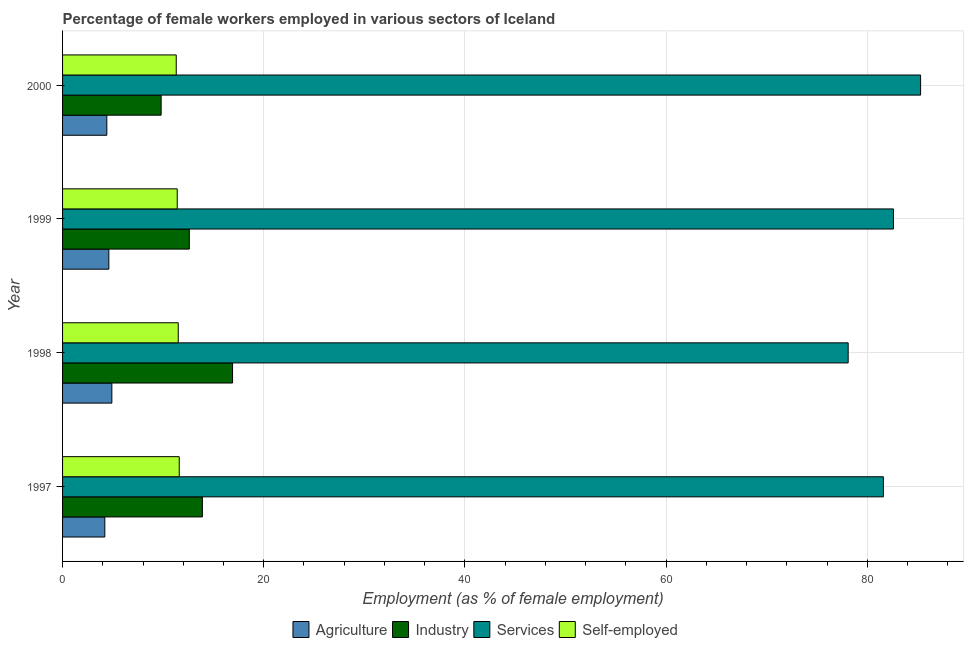How many groups of bars are there?
Provide a short and direct response. 4. Are the number of bars per tick equal to the number of legend labels?
Ensure brevity in your answer.  Yes. Are the number of bars on each tick of the Y-axis equal?
Ensure brevity in your answer.  Yes. How many bars are there on the 1st tick from the top?
Ensure brevity in your answer.  4. What is the percentage of self employed female workers in 1997?
Offer a very short reply. 11.6. Across all years, what is the maximum percentage of self employed female workers?
Your response must be concise. 11.6. Across all years, what is the minimum percentage of female workers in industry?
Provide a succinct answer. 9.8. In which year was the percentage of female workers in services minimum?
Provide a short and direct response. 1998. What is the total percentage of female workers in agriculture in the graph?
Make the answer very short. 18.1. What is the difference between the percentage of female workers in industry in 2000 and the percentage of female workers in services in 1999?
Provide a short and direct response. -72.8. What is the average percentage of self employed female workers per year?
Offer a terse response. 11.45. In the year 2000, what is the difference between the percentage of female workers in services and percentage of female workers in agriculture?
Give a very brief answer. 80.9. In how many years, is the percentage of female workers in agriculture greater than 64 %?
Offer a very short reply. 0. What is the ratio of the percentage of female workers in agriculture in 1998 to that in 2000?
Your response must be concise. 1.11. Is the percentage of female workers in agriculture in 1999 less than that in 2000?
Your answer should be very brief. No. Is the difference between the percentage of female workers in agriculture in 1997 and 1999 greater than the difference between the percentage of self employed female workers in 1997 and 1999?
Provide a short and direct response. No. What is the difference between the highest and the second highest percentage of female workers in services?
Ensure brevity in your answer.  2.7. What is the difference between the highest and the lowest percentage of female workers in industry?
Your response must be concise. 7.1. In how many years, is the percentage of female workers in industry greater than the average percentage of female workers in industry taken over all years?
Ensure brevity in your answer.  2. Is the sum of the percentage of female workers in industry in 1997 and 1999 greater than the maximum percentage of self employed female workers across all years?
Make the answer very short. Yes. What does the 2nd bar from the top in 1999 represents?
Keep it short and to the point. Services. What does the 1st bar from the bottom in 1998 represents?
Your answer should be very brief. Agriculture. How many bars are there?
Offer a terse response. 16. Are the values on the major ticks of X-axis written in scientific E-notation?
Make the answer very short. No. Does the graph contain any zero values?
Provide a succinct answer. No. Where does the legend appear in the graph?
Provide a succinct answer. Bottom center. How are the legend labels stacked?
Keep it short and to the point. Horizontal. What is the title of the graph?
Ensure brevity in your answer.  Percentage of female workers employed in various sectors of Iceland. What is the label or title of the X-axis?
Ensure brevity in your answer.  Employment (as % of female employment). What is the Employment (as % of female employment) of Agriculture in 1997?
Offer a very short reply. 4.2. What is the Employment (as % of female employment) in Industry in 1997?
Give a very brief answer. 13.9. What is the Employment (as % of female employment) in Services in 1997?
Make the answer very short. 81.6. What is the Employment (as % of female employment) in Self-employed in 1997?
Your response must be concise. 11.6. What is the Employment (as % of female employment) in Agriculture in 1998?
Give a very brief answer. 4.9. What is the Employment (as % of female employment) in Industry in 1998?
Ensure brevity in your answer.  16.9. What is the Employment (as % of female employment) of Services in 1998?
Offer a terse response. 78.1. What is the Employment (as % of female employment) of Self-employed in 1998?
Offer a terse response. 11.5. What is the Employment (as % of female employment) of Agriculture in 1999?
Offer a terse response. 4.6. What is the Employment (as % of female employment) of Industry in 1999?
Give a very brief answer. 12.6. What is the Employment (as % of female employment) of Services in 1999?
Give a very brief answer. 82.6. What is the Employment (as % of female employment) of Self-employed in 1999?
Ensure brevity in your answer.  11.4. What is the Employment (as % of female employment) in Agriculture in 2000?
Give a very brief answer. 4.4. What is the Employment (as % of female employment) in Industry in 2000?
Offer a terse response. 9.8. What is the Employment (as % of female employment) in Services in 2000?
Your answer should be compact. 85.3. What is the Employment (as % of female employment) of Self-employed in 2000?
Keep it short and to the point. 11.3. Across all years, what is the maximum Employment (as % of female employment) of Agriculture?
Provide a short and direct response. 4.9. Across all years, what is the maximum Employment (as % of female employment) in Industry?
Provide a succinct answer. 16.9. Across all years, what is the maximum Employment (as % of female employment) of Services?
Provide a short and direct response. 85.3. Across all years, what is the maximum Employment (as % of female employment) of Self-employed?
Provide a short and direct response. 11.6. Across all years, what is the minimum Employment (as % of female employment) of Agriculture?
Offer a terse response. 4.2. Across all years, what is the minimum Employment (as % of female employment) in Industry?
Keep it short and to the point. 9.8. Across all years, what is the minimum Employment (as % of female employment) in Services?
Your answer should be very brief. 78.1. Across all years, what is the minimum Employment (as % of female employment) of Self-employed?
Give a very brief answer. 11.3. What is the total Employment (as % of female employment) in Agriculture in the graph?
Keep it short and to the point. 18.1. What is the total Employment (as % of female employment) of Industry in the graph?
Provide a short and direct response. 53.2. What is the total Employment (as % of female employment) of Services in the graph?
Offer a terse response. 327.6. What is the total Employment (as % of female employment) of Self-employed in the graph?
Keep it short and to the point. 45.8. What is the difference between the Employment (as % of female employment) of Agriculture in 1997 and that in 1998?
Provide a short and direct response. -0.7. What is the difference between the Employment (as % of female employment) in Industry in 1997 and that in 1998?
Provide a short and direct response. -3. What is the difference between the Employment (as % of female employment) in Agriculture in 1997 and that in 1999?
Offer a very short reply. -0.4. What is the difference between the Employment (as % of female employment) of Self-employed in 1997 and that in 1999?
Your answer should be very brief. 0.2. What is the difference between the Employment (as % of female employment) in Services in 1997 and that in 2000?
Offer a very short reply. -3.7. What is the difference between the Employment (as % of female employment) in Industry in 1998 and that in 1999?
Your answer should be very brief. 4.3. What is the difference between the Employment (as % of female employment) of Services in 1998 and that in 1999?
Make the answer very short. -4.5. What is the difference between the Employment (as % of female employment) of Self-employed in 1998 and that in 1999?
Provide a succinct answer. 0.1. What is the difference between the Employment (as % of female employment) in Agriculture in 1998 and that in 2000?
Your answer should be compact. 0.5. What is the difference between the Employment (as % of female employment) of Industry in 1998 and that in 2000?
Keep it short and to the point. 7.1. What is the difference between the Employment (as % of female employment) of Agriculture in 1997 and the Employment (as % of female employment) of Industry in 1998?
Make the answer very short. -12.7. What is the difference between the Employment (as % of female employment) of Agriculture in 1997 and the Employment (as % of female employment) of Services in 1998?
Give a very brief answer. -73.9. What is the difference between the Employment (as % of female employment) of Industry in 1997 and the Employment (as % of female employment) of Services in 1998?
Offer a terse response. -64.2. What is the difference between the Employment (as % of female employment) of Services in 1997 and the Employment (as % of female employment) of Self-employed in 1998?
Offer a terse response. 70.1. What is the difference between the Employment (as % of female employment) in Agriculture in 1997 and the Employment (as % of female employment) in Services in 1999?
Your answer should be compact. -78.4. What is the difference between the Employment (as % of female employment) in Industry in 1997 and the Employment (as % of female employment) in Services in 1999?
Your answer should be very brief. -68.7. What is the difference between the Employment (as % of female employment) of Services in 1997 and the Employment (as % of female employment) of Self-employed in 1999?
Ensure brevity in your answer.  70.2. What is the difference between the Employment (as % of female employment) of Agriculture in 1997 and the Employment (as % of female employment) of Services in 2000?
Provide a succinct answer. -81.1. What is the difference between the Employment (as % of female employment) in Agriculture in 1997 and the Employment (as % of female employment) in Self-employed in 2000?
Your answer should be very brief. -7.1. What is the difference between the Employment (as % of female employment) of Industry in 1997 and the Employment (as % of female employment) of Services in 2000?
Keep it short and to the point. -71.4. What is the difference between the Employment (as % of female employment) in Industry in 1997 and the Employment (as % of female employment) in Self-employed in 2000?
Provide a short and direct response. 2.6. What is the difference between the Employment (as % of female employment) of Services in 1997 and the Employment (as % of female employment) of Self-employed in 2000?
Make the answer very short. 70.3. What is the difference between the Employment (as % of female employment) in Agriculture in 1998 and the Employment (as % of female employment) in Industry in 1999?
Offer a very short reply. -7.7. What is the difference between the Employment (as % of female employment) in Agriculture in 1998 and the Employment (as % of female employment) in Services in 1999?
Make the answer very short. -77.7. What is the difference between the Employment (as % of female employment) of Agriculture in 1998 and the Employment (as % of female employment) of Self-employed in 1999?
Offer a very short reply. -6.5. What is the difference between the Employment (as % of female employment) in Industry in 1998 and the Employment (as % of female employment) in Services in 1999?
Your response must be concise. -65.7. What is the difference between the Employment (as % of female employment) in Industry in 1998 and the Employment (as % of female employment) in Self-employed in 1999?
Offer a terse response. 5.5. What is the difference between the Employment (as % of female employment) in Services in 1998 and the Employment (as % of female employment) in Self-employed in 1999?
Your answer should be very brief. 66.7. What is the difference between the Employment (as % of female employment) in Agriculture in 1998 and the Employment (as % of female employment) in Services in 2000?
Offer a terse response. -80.4. What is the difference between the Employment (as % of female employment) of Agriculture in 1998 and the Employment (as % of female employment) of Self-employed in 2000?
Your response must be concise. -6.4. What is the difference between the Employment (as % of female employment) of Industry in 1998 and the Employment (as % of female employment) of Services in 2000?
Provide a succinct answer. -68.4. What is the difference between the Employment (as % of female employment) in Services in 1998 and the Employment (as % of female employment) in Self-employed in 2000?
Your answer should be compact. 66.8. What is the difference between the Employment (as % of female employment) of Agriculture in 1999 and the Employment (as % of female employment) of Services in 2000?
Your answer should be compact. -80.7. What is the difference between the Employment (as % of female employment) of Industry in 1999 and the Employment (as % of female employment) of Services in 2000?
Offer a terse response. -72.7. What is the difference between the Employment (as % of female employment) in Services in 1999 and the Employment (as % of female employment) in Self-employed in 2000?
Keep it short and to the point. 71.3. What is the average Employment (as % of female employment) in Agriculture per year?
Offer a terse response. 4.53. What is the average Employment (as % of female employment) of Services per year?
Ensure brevity in your answer.  81.9. What is the average Employment (as % of female employment) of Self-employed per year?
Your answer should be very brief. 11.45. In the year 1997, what is the difference between the Employment (as % of female employment) of Agriculture and Employment (as % of female employment) of Services?
Keep it short and to the point. -77.4. In the year 1997, what is the difference between the Employment (as % of female employment) of Industry and Employment (as % of female employment) of Services?
Offer a terse response. -67.7. In the year 1997, what is the difference between the Employment (as % of female employment) in Services and Employment (as % of female employment) in Self-employed?
Your answer should be compact. 70. In the year 1998, what is the difference between the Employment (as % of female employment) in Agriculture and Employment (as % of female employment) in Services?
Give a very brief answer. -73.2. In the year 1998, what is the difference between the Employment (as % of female employment) in Industry and Employment (as % of female employment) in Services?
Your answer should be compact. -61.2. In the year 1998, what is the difference between the Employment (as % of female employment) of Industry and Employment (as % of female employment) of Self-employed?
Offer a terse response. 5.4. In the year 1998, what is the difference between the Employment (as % of female employment) in Services and Employment (as % of female employment) in Self-employed?
Your answer should be compact. 66.6. In the year 1999, what is the difference between the Employment (as % of female employment) in Agriculture and Employment (as % of female employment) in Industry?
Give a very brief answer. -8. In the year 1999, what is the difference between the Employment (as % of female employment) of Agriculture and Employment (as % of female employment) of Services?
Provide a short and direct response. -78. In the year 1999, what is the difference between the Employment (as % of female employment) of Industry and Employment (as % of female employment) of Services?
Your response must be concise. -70. In the year 1999, what is the difference between the Employment (as % of female employment) of Industry and Employment (as % of female employment) of Self-employed?
Provide a succinct answer. 1.2. In the year 1999, what is the difference between the Employment (as % of female employment) of Services and Employment (as % of female employment) of Self-employed?
Give a very brief answer. 71.2. In the year 2000, what is the difference between the Employment (as % of female employment) in Agriculture and Employment (as % of female employment) in Services?
Offer a terse response. -80.9. In the year 2000, what is the difference between the Employment (as % of female employment) in Agriculture and Employment (as % of female employment) in Self-employed?
Give a very brief answer. -6.9. In the year 2000, what is the difference between the Employment (as % of female employment) of Industry and Employment (as % of female employment) of Services?
Give a very brief answer. -75.5. In the year 2000, what is the difference between the Employment (as % of female employment) of Industry and Employment (as % of female employment) of Self-employed?
Ensure brevity in your answer.  -1.5. In the year 2000, what is the difference between the Employment (as % of female employment) of Services and Employment (as % of female employment) of Self-employed?
Give a very brief answer. 74. What is the ratio of the Employment (as % of female employment) of Agriculture in 1997 to that in 1998?
Give a very brief answer. 0.86. What is the ratio of the Employment (as % of female employment) in Industry in 1997 to that in 1998?
Provide a short and direct response. 0.82. What is the ratio of the Employment (as % of female employment) of Services in 1997 to that in 1998?
Your answer should be compact. 1.04. What is the ratio of the Employment (as % of female employment) of Self-employed in 1997 to that in 1998?
Your answer should be very brief. 1.01. What is the ratio of the Employment (as % of female employment) of Industry in 1997 to that in 1999?
Keep it short and to the point. 1.1. What is the ratio of the Employment (as % of female employment) in Services in 1997 to that in 1999?
Offer a terse response. 0.99. What is the ratio of the Employment (as % of female employment) of Self-employed in 1997 to that in 1999?
Keep it short and to the point. 1.02. What is the ratio of the Employment (as % of female employment) of Agriculture in 1997 to that in 2000?
Your answer should be very brief. 0.95. What is the ratio of the Employment (as % of female employment) in Industry in 1997 to that in 2000?
Make the answer very short. 1.42. What is the ratio of the Employment (as % of female employment) in Services in 1997 to that in 2000?
Make the answer very short. 0.96. What is the ratio of the Employment (as % of female employment) of Self-employed in 1997 to that in 2000?
Make the answer very short. 1.03. What is the ratio of the Employment (as % of female employment) of Agriculture in 1998 to that in 1999?
Ensure brevity in your answer.  1.07. What is the ratio of the Employment (as % of female employment) in Industry in 1998 to that in 1999?
Offer a very short reply. 1.34. What is the ratio of the Employment (as % of female employment) of Services in 1998 to that in 1999?
Your response must be concise. 0.95. What is the ratio of the Employment (as % of female employment) of Self-employed in 1998 to that in 1999?
Make the answer very short. 1.01. What is the ratio of the Employment (as % of female employment) of Agriculture in 1998 to that in 2000?
Provide a succinct answer. 1.11. What is the ratio of the Employment (as % of female employment) in Industry in 1998 to that in 2000?
Provide a short and direct response. 1.72. What is the ratio of the Employment (as % of female employment) in Services in 1998 to that in 2000?
Offer a terse response. 0.92. What is the ratio of the Employment (as % of female employment) in Self-employed in 1998 to that in 2000?
Ensure brevity in your answer.  1.02. What is the ratio of the Employment (as % of female employment) in Agriculture in 1999 to that in 2000?
Ensure brevity in your answer.  1.05. What is the ratio of the Employment (as % of female employment) in Services in 1999 to that in 2000?
Your answer should be very brief. 0.97. What is the ratio of the Employment (as % of female employment) in Self-employed in 1999 to that in 2000?
Ensure brevity in your answer.  1.01. What is the difference between the highest and the second highest Employment (as % of female employment) in Agriculture?
Your answer should be very brief. 0.3. What is the difference between the highest and the second highest Employment (as % of female employment) in Services?
Make the answer very short. 2.7. 